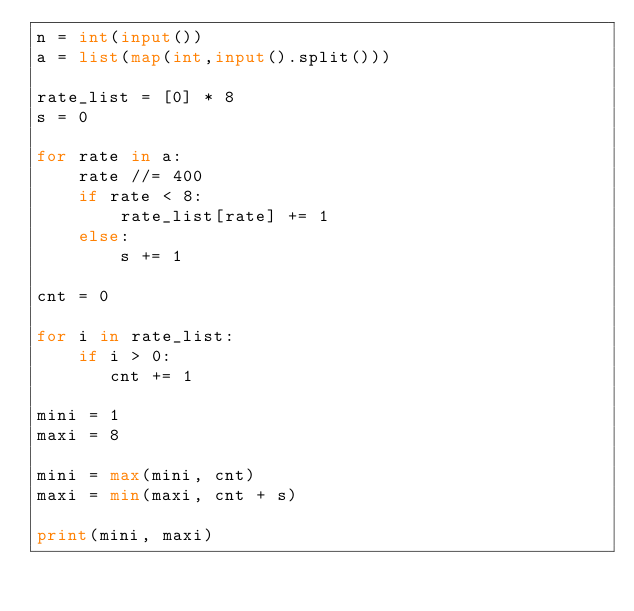<code> <loc_0><loc_0><loc_500><loc_500><_Python_>n = int(input())
a = list(map(int,input().split()))

rate_list = [0] * 8
s = 0

for rate in a:
    rate //= 400
    if rate < 8:
        rate_list[rate] += 1
    else:
        s += 1

cnt = 0

for i in rate_list:
    if i > 0:
       cnt += 1

mini = 1
maxi = 8

mini = max(mini, cnt)
maxi = min(maxi, cnt + s)

print(mini, maxi)</code> 